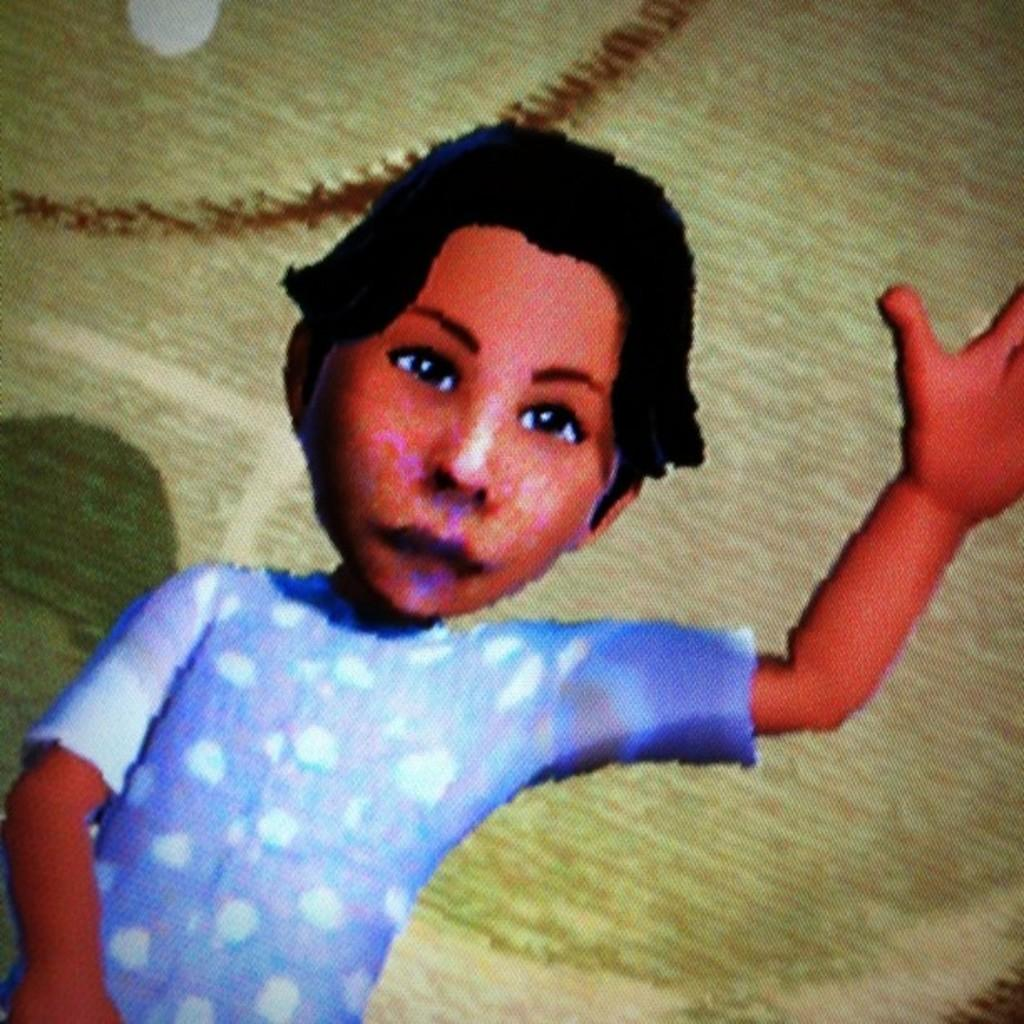What is the main subject in the foreground of the image? There is an animated boy in the foreground of the image. What is the boy doing in the image? The boy is raising one hand up in the air. What type of design can be seen on the boy's eyes in the image? There is no information about the boy's eyes or any design on them in the provided facts. 